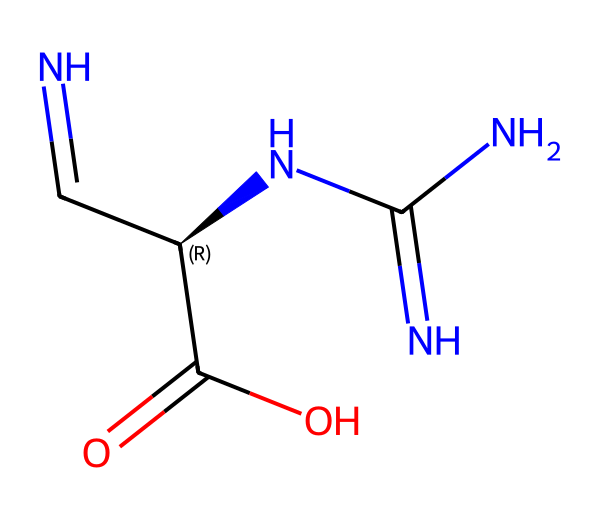What type of functional groups are present in this structure? The chemical structure contains amine (indicated by -N), amide (indicated by -C(=O)N-), and carboxylic acid (indicated by -C(=O)O) functional groups.
Answer: amine, amide, carboxylic acid How many nitrogen atoms are in this compound? By analyzing the SMILES representation, we can count the nitrogen atoms: there are three distinct nitrogen atoms present in the chemical structure.
Answer: three What is the stereochemistry present in this compound? The SMILES notation includes an '@' symbol, indicating that there is one chiral center at the carbon atom adjacent to a nitrogen (N) group (marked as C@H). This allows for the possibility of different stereoisomers.
Answer: one chiral center Which part of the structure indicates potential reactivity typical of carbenes? The N=C segment suggests the presence of a carbene, as carbenes are characterized by a carbon atom that has two valences filled typically with a double bond, and is often bonded to a nitrogen atom in this case, which allows for it to act as a reactive intermediate.
Answer: N=C What is the total number of atoms in this chemical? To find the total number of atoms, we count the individual atom types: 5 carbon (C), 3 nitrogen (N), 1 oxygen (O), and 1 hydrogen (H) totaling 10 atoms in the compound.
Answer: ten What potential agricultural application could arise from this compound? Given its structural characteristics, this compound could be explored as an environmentally-friendly pesticide, utilizing its reactivity and functional groups to target pests while being safer for the ecosystem.
Answer: environmentally-friendly pesticide 